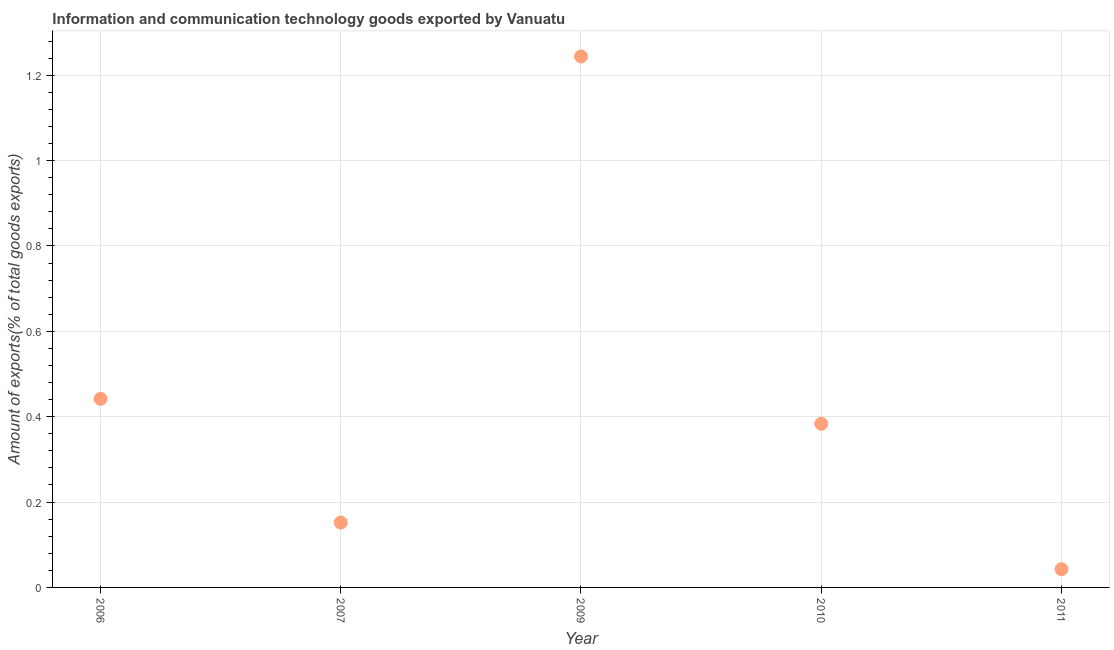What is the amount of ict goods exports in 2010?
Ensure brevity in your answer.  0.38. Across all years, what is the maximum amount of ict goods exports?
Offer a very short reply. 1.24. Across all years, what is the minimum amount of ict goods exports?
Your answer should be compact. 0.04. In which year was the amount of ict goods exports maximum?
Your response must be concise. 2009. In which year was the amount of ict goods exports minimum?
Give a very brief answer. 2011. What is the sum of the amount of ict goods exports?
Keep it short and to the point. 2.26. What is the difference between the amount of ict goods exports in 2007 and 2010?
Ensure brevity in your answer.  -0.23. What is the average amount of ict goods exports per year?
Provide a short and direct response. 0.45. What is the median amount of ict goods exports?
Ensure brevity in your answer.  0.38. In how many years, is the amount of ict goods exports greater than 0.92 %?
Make the answer very short. 1. What is the ratio of the amount of ict goods exports in 2006 to that in 2007?
Keep it short and to the point. 2.91. What is the difference between the highest and the second highest amount of ict goods exports?
Offer a terse response. 0.8. Is the sum of the amount of ict goods exports in 2010 and 2011 greater than the maximum amount of ict goods exports across all years?
Provide a succinct answer. No. What is the difference between the highest and the lowest amount of ict goods exports?
Offer a very short reply. 1.2. In how many years, is the amount of ict goods exports greater than the average amount of ict goods exports taken over all years?
Keep it short and to the point. 1. How many dotlines are there?
Give a very brief answer. 1. What is the difference between two consecutive major ticks on the Y-axis?
Provide a succinct answer. 0.2. Does the graph contain grids?
Offer a terse response. Yes. What is the title of the graph?
Your answer should be very brief. Information and communication technology goods exported by Vanuatu. What is the label or title of the Y-axis?
Your answer should be very brief. Amount of exports(% of total goods exports). What is the Amount of exports(% of total goods exports) in 2006?
Make the answer very short. 0.44. What is the Amount of exports(% of total goods exports) in 2007?
Offer a terse response. 0.15. What is the Amount of exports(% of total goods exports) in 2009?
Ensure brevity in your answer.  1.24. What is the Amount of exports(% of total goods exports) in 2010?
Offer a very short reply. 0.38. What is the Amount of exports(% of total goods exports) in 2011?
Your answer should be compact. 0.04. What is the difference between the Amount of exports(% of total goods exports) in 2006 and 2007?
Make the answer very short. 0.29. What is the difference between the Amount of exports(% of total goods exports) in 2006 and 2009?
Make the answer very short. -0.8. What is the difference between the Amount of exports(% of total goods exports) in 2006 and 2010?
Give a very brief answer. 0.06. What is the difference between the Amount of exports(% of total goods exports) in 2006 and 2011?
Your answer should be compact. 0.4. What is the difference between the Amount of exports(% of total goods exports) in 2007 and 2009?
Ensure brevity in your answer.  -1.09. What is the difference between the Amount of exports(% of total goods exports) in 2007 and 2010?
Your response must be concise. -0.23. What is the difference between the Amount of exports(% of total goods exports) in 2007 and 2011?
Your response must be concise. 0.11. What is the difference between the Amount of exports(% of total goods exports) in 2009 and 2010?
Keep it short and to the point. 0.86. What is the difference between the Amount of exports(% of total goods exports) in 2009 and 2011?
Your answer should be very brief. 1.2. What is the difference between the Amount of exports(% of total goods exports) in 2010 and 2011?
Your answer should be very brief. 0.34. What is the ratio of the Amount of exports(% of total goods exports) in 2006 to that in 2007?
Provide a short and direct response. 2.91. What is the ratio of the Amount of exports(% of total goods exports) in 2006 to that in 2009?
Offer a very short reply. 0.35. What is the ratio of the Amount of exports(% of total goods exports) in 2006 to that in 2010?
Give a very brief answer. 1.15. What is the ratio of the Amount of exports(% of total goods exports) in 2006 to that in 2011?
Your answer should be compact. 10.34. What is the ratio of the Amount of exports(% of total goods exports) in 2007 to that in 2009?
Provide a short and direct response. 0.12. What is the ratio of the Amount of exports(% of total goods exports) in 2007 to that in 2010?
Keep it short and to the point. 0.4. What is the ratio of the Amount of exports(% of total goods exports) in 2007 to that in 2011?
Offer a very short reply. 3.56. What is the ratio of the Amount of exports(% of total goods exports) in 2009 to that in 2010?
Give a very brief answer. 3.24. What is the ratio of the Amount of exports(% of total goods exports) in 2009 to that in 2011?
Give a very brief answer. 29.11. What is the ratio of the Amount of exports(% of total goods exports) in 2010 to that in 2011?
Your answer should be compact. 8.97. 